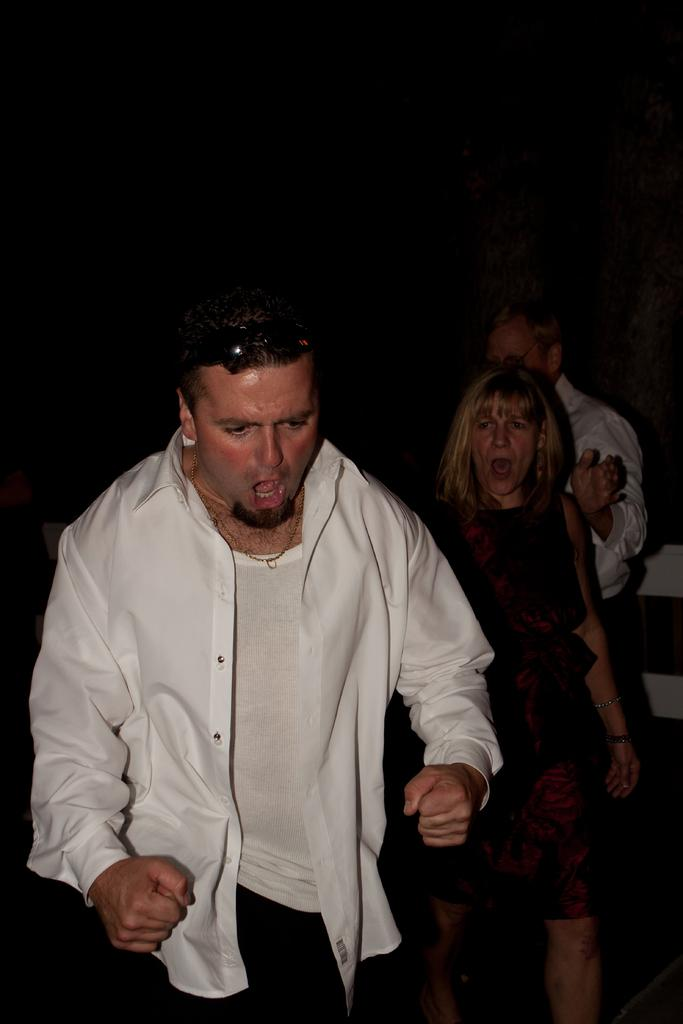What is the overall tone of the image based on the background? The background of the image is dark, which might suggest a dramatic or intense scene. How many people are in the image? There are people in the image, including a man and a woman. What are the man and the woman doing in the image? The man and the woman appear to be screaming in the image. Who is the owner of the rings in the image? There are no rings present in the image, so it is not possible to determine the owner. 